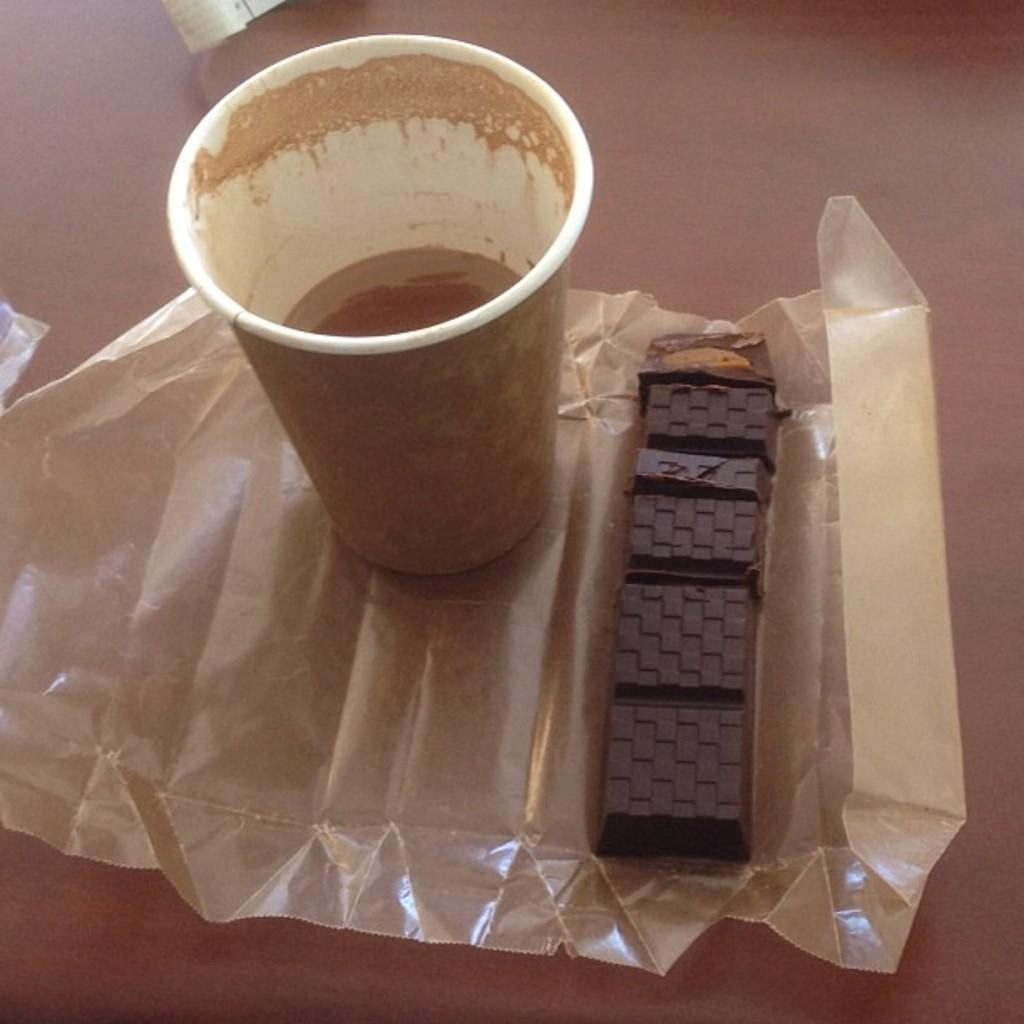What is in the coffee cup that is visible in the image? There is a half-filled coffee cup in the image. What type of food item can be seen in the image? There is a chocolate bar in the image. What is the material of the wrapper in the image? The wrapper in the image is likely made of paper or plastic. What is the color of the table in the image? The table in the image is brown. Can you see any attempts to smoke in the image? There is no indication of smoking or any attempts to smoke in the image. What type of floor is visible in the image? The provided facts do not mention the floor, so we cannot determine its type from the image. 